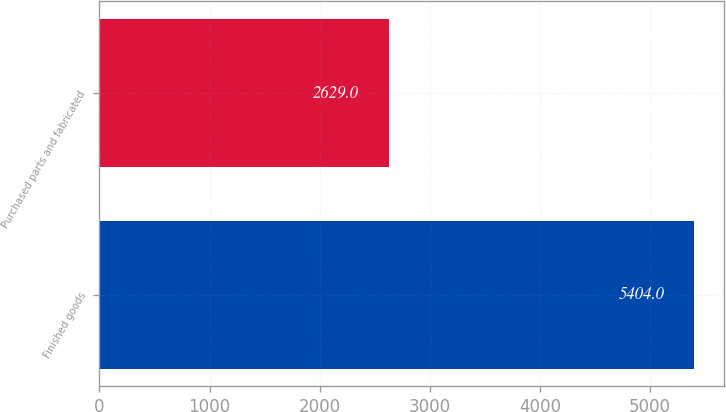<chart> <loc_0><loc_0><loc_500><loc_500><bar_chart><fcel>Finished goods<fcel>Purchased parts and fabricated<nl><fcel>5404<fcel>2629<nl></chart> 